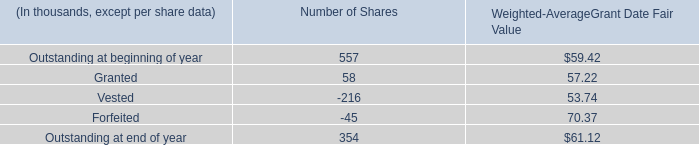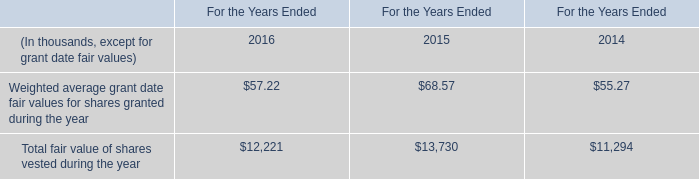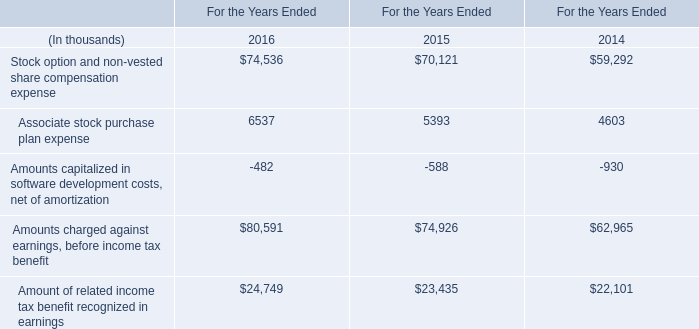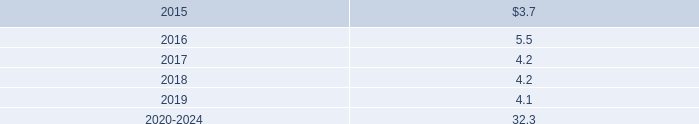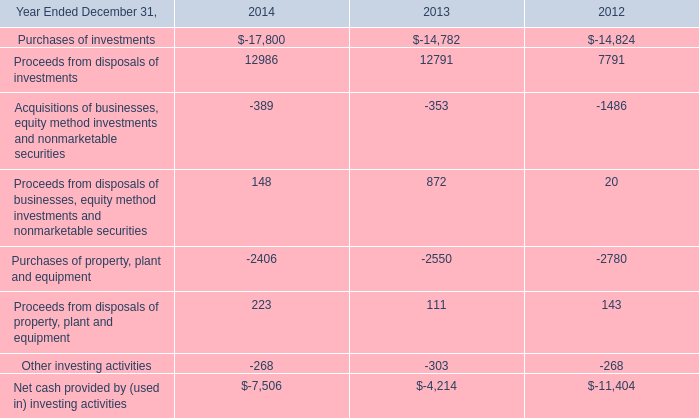what was the average purchase price of company repurchased shares in 2013? 
Computations: (497.0 / 6.8)
Answer: 73.08824. 